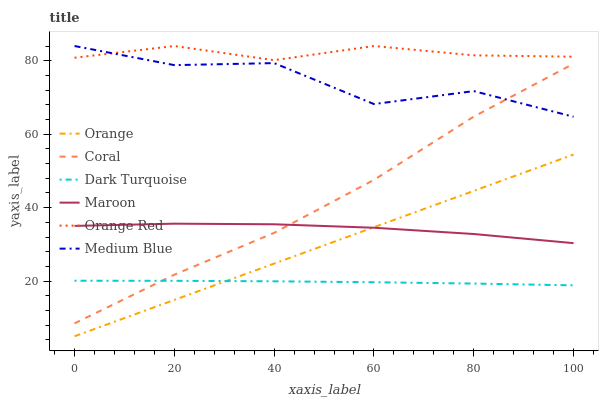Does Dark Turquoise have the minimum area under the curve?
Answer yes or no. Yes. Does Orange Red have the maximum area under the curve?
Answer yes or no. Yes. Does Coral have the minimum area under the curve?
Answer yes or no. No. Does Coral have the maximum area under the curve?
Answer yes or no. No. Is Orange the smoothest?
Answer yes or no. Yes. Is Medium Blue the roughest?
Answer yes or no. Yes. Is Coral the smoothest?
Answer yes or no. No. Is Coral the roughest?
Answer yes or no. No. Does Orange have the lowest value?
Answer yes or no. Yes. Does Coral have the lowest value?
Answer yes or no. No. Does Orange Red have the highest value?
Answer yes or no. Yes. Does Coral have the highest value?
Answer yes or no. No. Is Dark Turquoise less than Maroon?
Answer yes or no. Yes. Is Orange Red greater than Maroon?
Answer yes or no. Yes. Does Coral intersect Dark Turquoise?
Answer yes or no. Yes. Is Coral less than Dark Turquoise?
Answer yes or no. No. Is Coral greater than Dark Turquoise?
Answer yes or no. No. Does Dark Turquoise intersect Maroon?
Answer yes or no. No. 